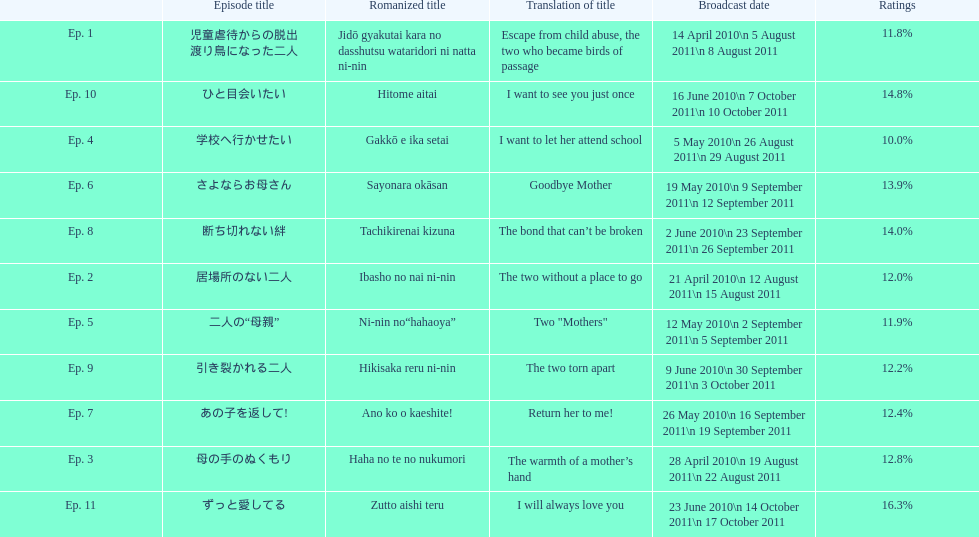What as the percentage total of ratings for episode 8? 14.0%. 